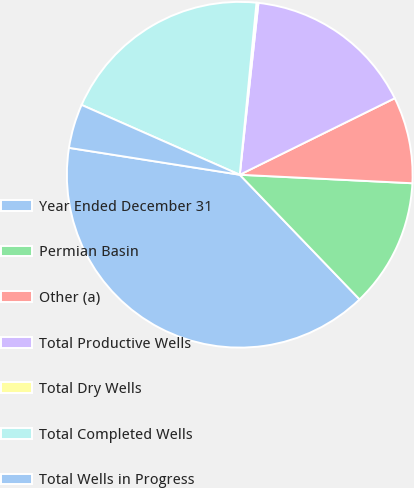<chart> <loc_0><loc_0><loc_500><loc_500><pie_chart><fcel>Year Ended December 31<fcel>Permian Basin<fcel>Other (a)<fcel>Total Productive Wells<fcel>Total Dry Wells<fcel>Total Completed Wells<fcel>Total Wells in Progress<nl><fcel>39.68%<fcel>12.03%<fcel>8.08%<fcel>15.98%<fcel>0.18%<fcel>19.93%<fcel>4.13%<nl></chart> 